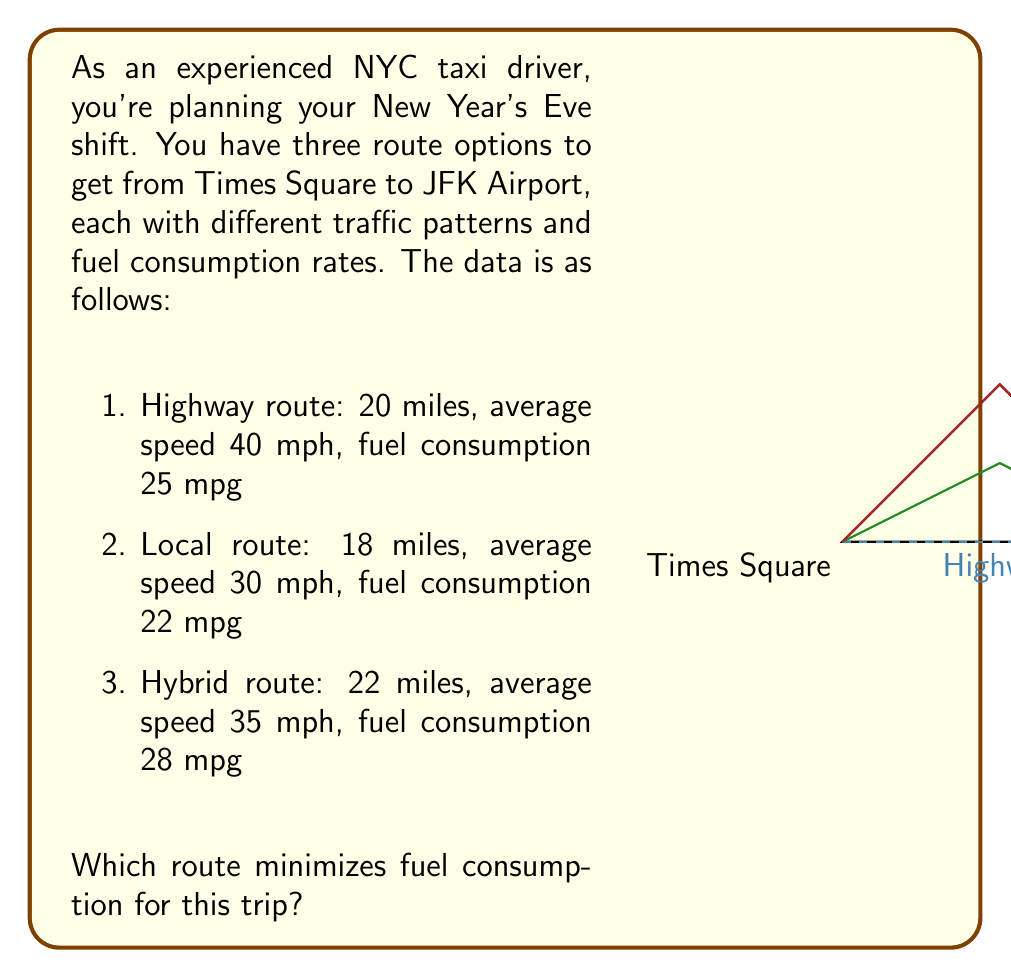What is the answer to this math problem? Let's approach this step-by-step:

1) First, we need to calculate the fuel consumption for each route. To do this, we'll use the formula:

   Fuel consumed = Distance / Fuel efficiency

2) For the Highway route:
   $$\text{Fuel consumed} = \frac{20 \text{ miles}}{25 \text{ mpg}} = 0.8 \text{ gallons}$$

3) For the Local route:
   $$\text{Fuel consumed} = \frac{18 \text{ miles}}{22 \text{ mpg}} \approx 0.8182 \text{ gallons}$$

4) For the Hybrid route:
   $$\text{Fuel consumed} = \frac{22 \text{ miles}}{28 \text{ mpg}} \approx 0.7857 \text{ gallons}$$

5) Comparing these results:
   Highway: 0.8000 gallons
   Local: 0.8182 gallons
   Hybrid: 0.7857 gallons

6) The Hybrid route consumes the least amount of fuel.

Note: While the question doesn't ask for time, it's worth noting that the Hybrid route, despite being longer, is also faster than the Local route due to higher average speed, which could be beneficial on a busy night like New Year's Eve.
Answer: Hybrid route 